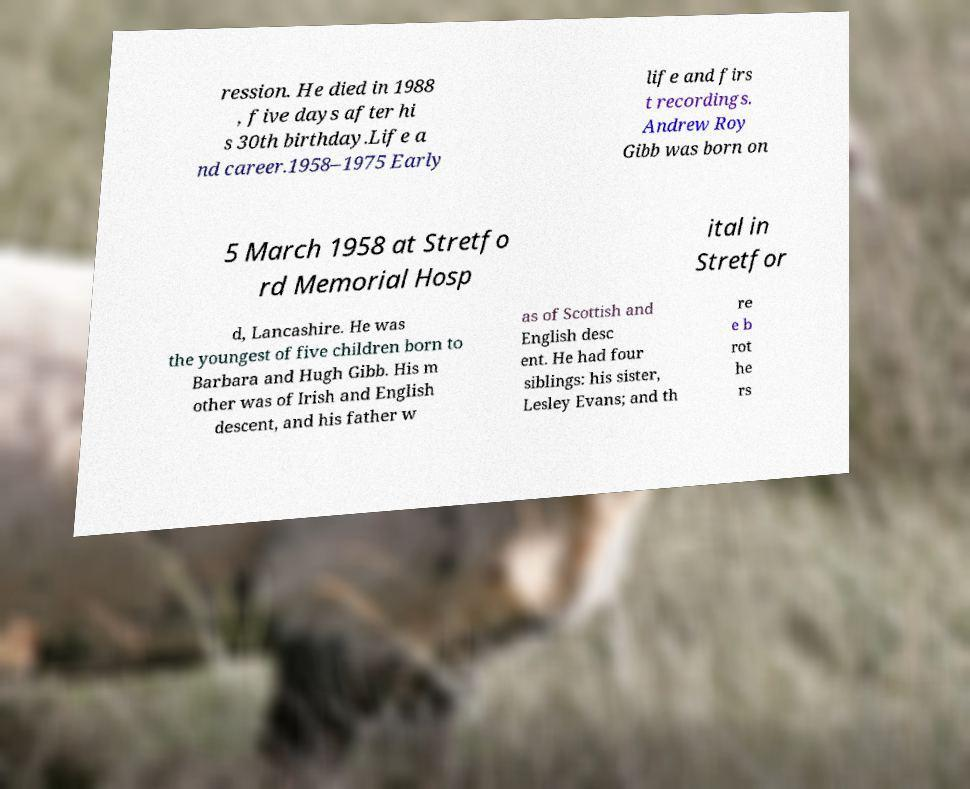Can you accurately transcribe the text from the provided image for me? ression. He died in 1988 , five days after hi s 30th birthday.Life a nd career.1958–1975 Early life and firs t recordings. Andrew Roy Gibb was born on 5 March 1958 at Stretfo rd Memorial Hosp ital in Stretfor d, Lancashire. He was the youngest of five children born to Barbara and Hugh Gibb. His m other was of Irish and English descent, and his father w as of Scottish and English desc ent. He had four siblings: his sister, Lesley Evans; and th re e b rot he rs 